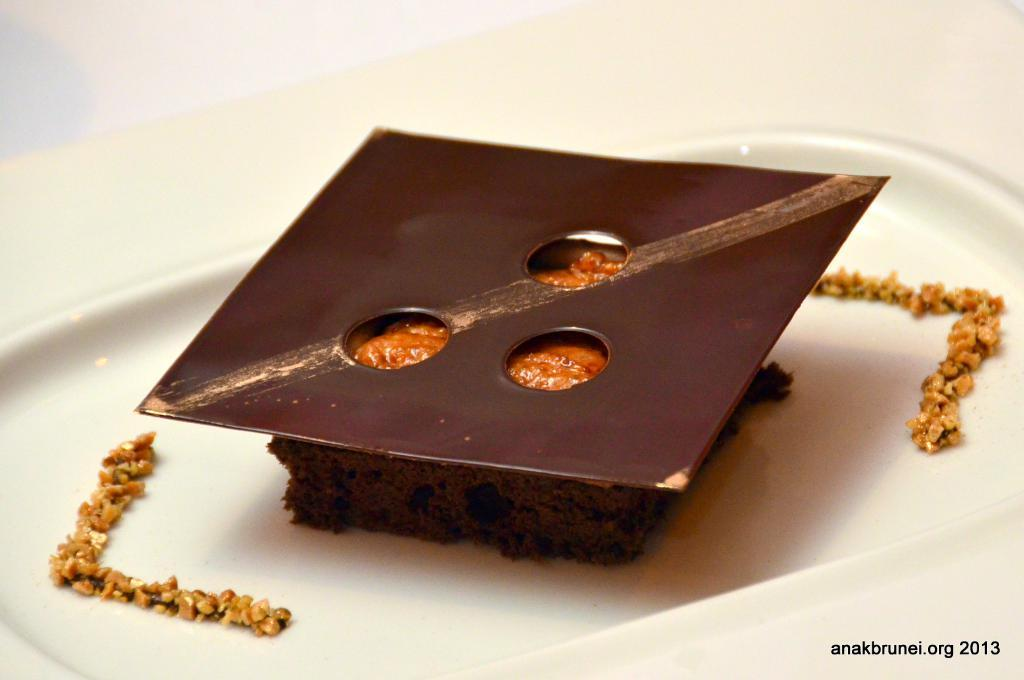What is on the plate that is visible in the image? There is food on a plate in the image. What color is the plate? The plate is white. Where is the text located in the image? The text is at the bottom right of the image. What type of story is being told by the birds in the image? There are no birds present in the image, so no story can be told by them. 